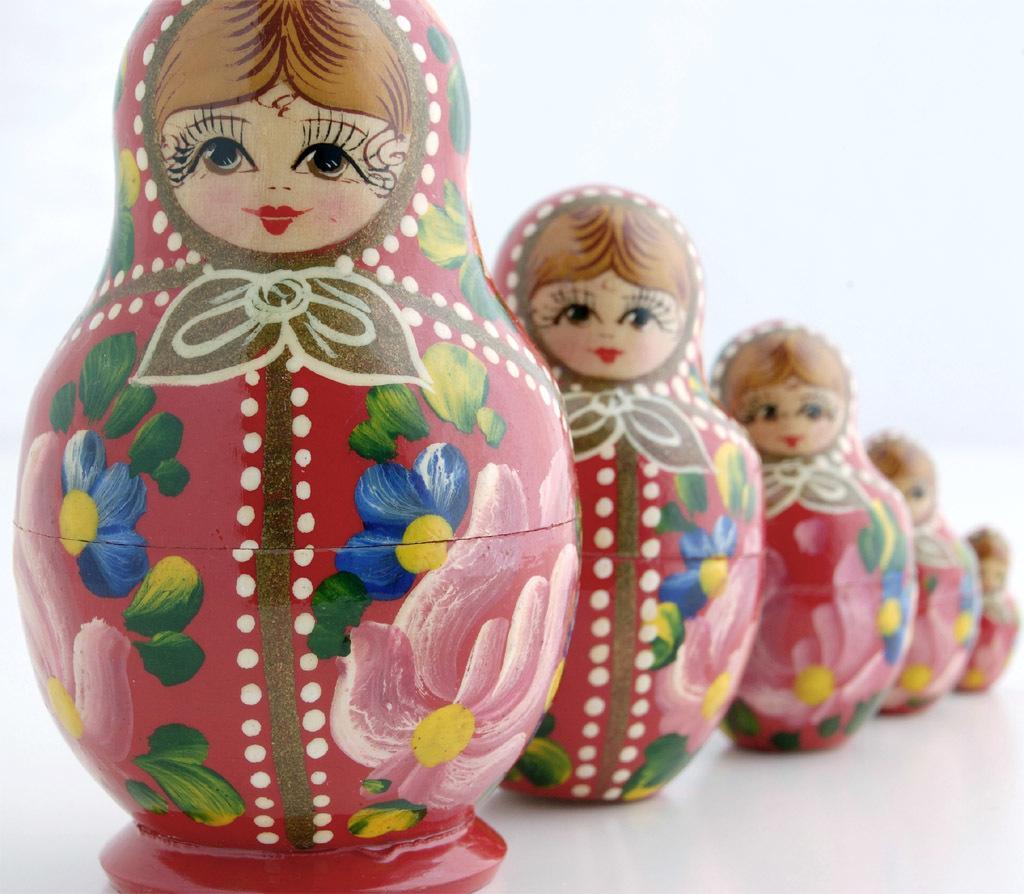Describe this image in one or two sentences. In this image we can see five toys. On the toys we can see the painting. The background of the image is white. 